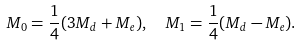<formula> <loc_0><loc_0><loc_500><loc_500>M _ { 0 } = { \frac { 1 } { 4 } } ( 3 M _ { d } + M _ { e } ) , \ \ M _ { 1 } = { \frac { 1 } { 4 } } ( M _ { d } - M _ { e } ) .</formula> 